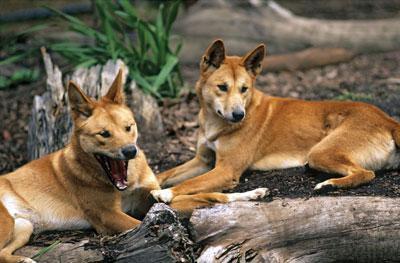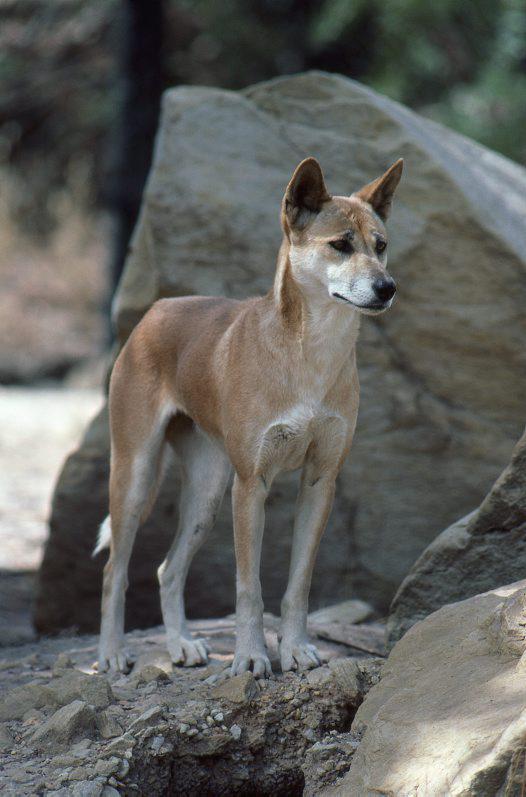The first image is the image on the left, the second image is the image on the right. For the images displayed, is the sentence "The dog on the right image is running." factually correct? Answer yes or no. No. 